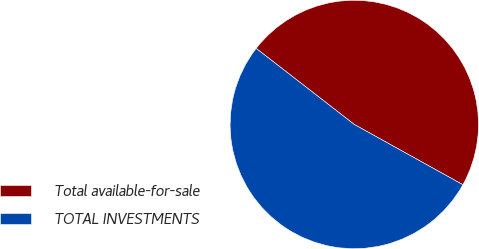Convert chart to OTSL. <chart><loc_0><loc_0><loc_500><loc_500><pie_chart><fcel>Total available-for-sale<fcel>TOTAL INVESTMENTS<nl><fcel>47.57%<fcel>52.43%<nl></chart> 